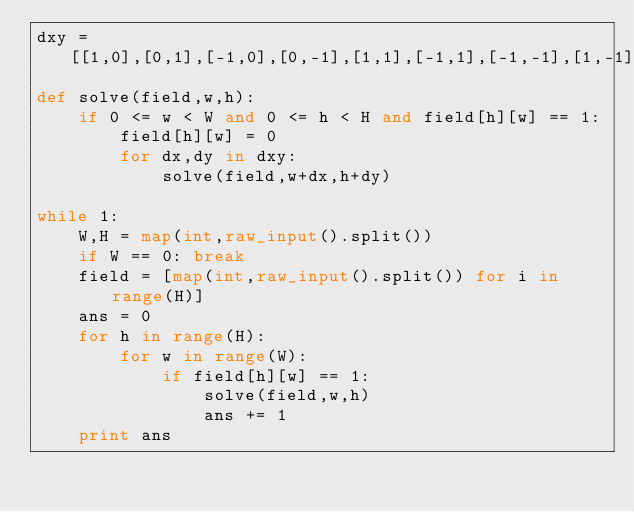Convert code to text. <code><loc_0><loc_0><loc_500><loc_500><_Python_>dxy = [[1,0],[0,1],[-1,0],[0,-1],[1,1],[-1,1],[-1,-1],[1,-1]]
def solve(field,w,h):
	if 0 <= w < W and 0 <= h < H and field[h][w] == 1:
		field[h][w] = 0
		for dx,dy in dxy:
			solve(field,w+dx,h+dy)

while 1:
	W,H = map(int,raw_input().split())
	if W == 0: break
	field = [map(int,raw_input().split()) for i in range(H)]
	ans = 0
	for h in range(H):
		for w in range(W):
			if field[h][w] == 1:
				solve(field,w,h)
				ans += 1
	print ans</code> 